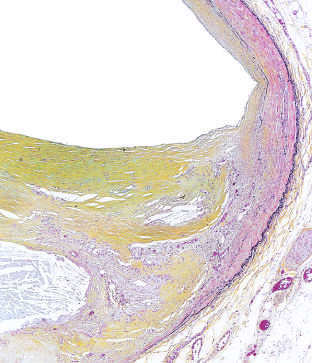s the intact basement membrane shown in the figure, stained for elastin black?
Answer the question using a single word or phrase. No 